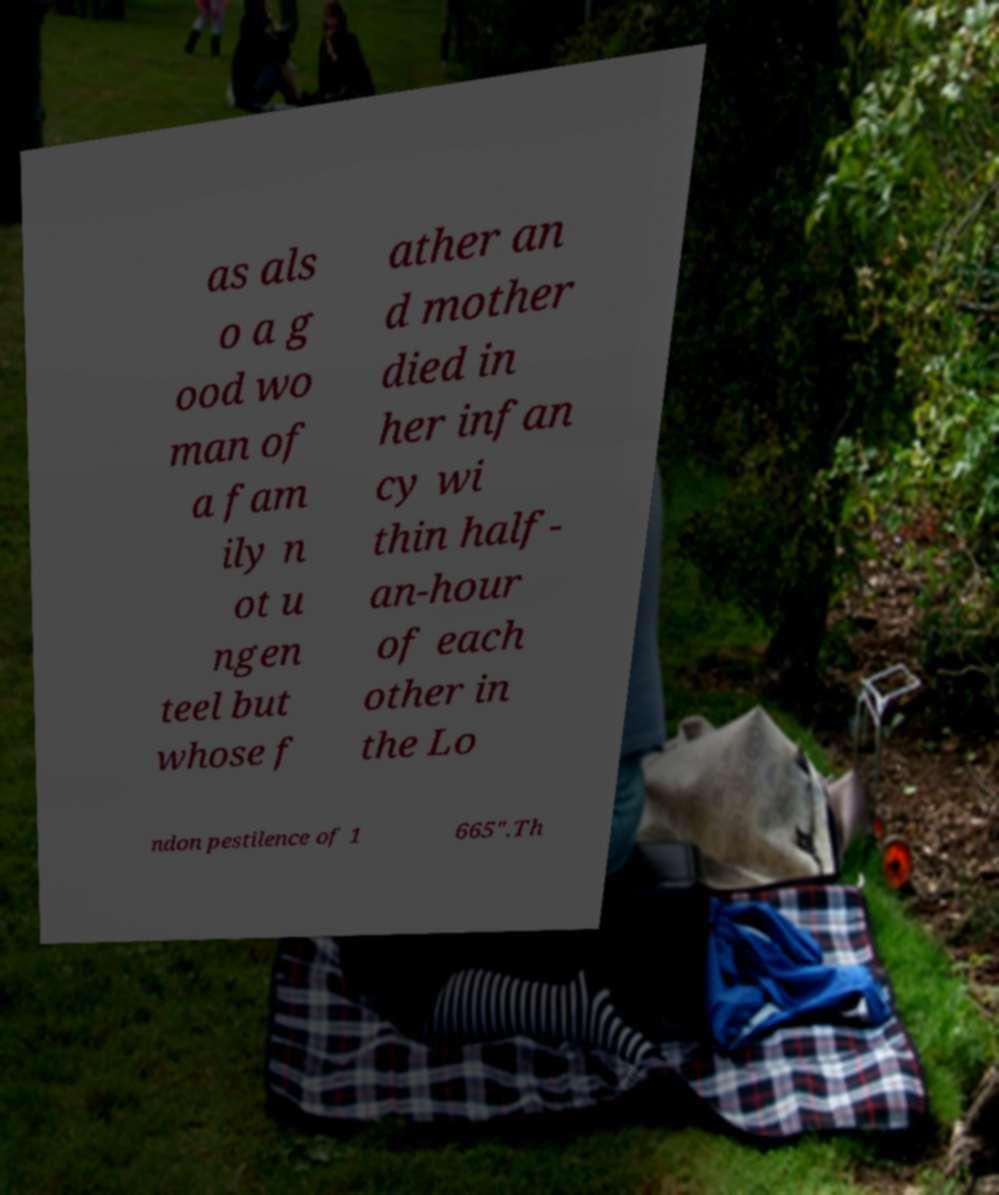Please read and relay the text visible in this image. What does it say? as als o a g ood wo man of a fam ily n ot u ngen teel but whose f ather an d mother died in her infan cy wi thin half- an-hour of each other in the Lo ndon pestilence of 1 665".Th 